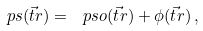Convert formula to latex. <formula><loc_0><loc_0><loc_500><loc_500>\ p s ( \vec { t } { r } ) = \ p s o ( \vec { t } { r } ) + \phi ( \vec { t } { r } ) \, ,</formula> 